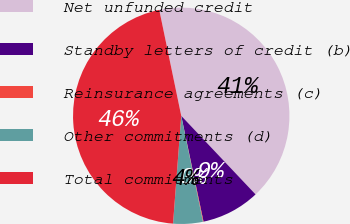<chart> <loc_0><loc_0><loc_500><loc_500><pie_chart><fcel>Net unfunded credit<fcel>Standby letters of credit (b)<fcel>Reinsurance agreements (c)<fcel>Other commitments (d)<fcel>Total commitments<nl><fcel>41.2%<fcel>8.75%<fcel>0.09%<fcel>4.42%<fcel>45.53%<nl></chart> 